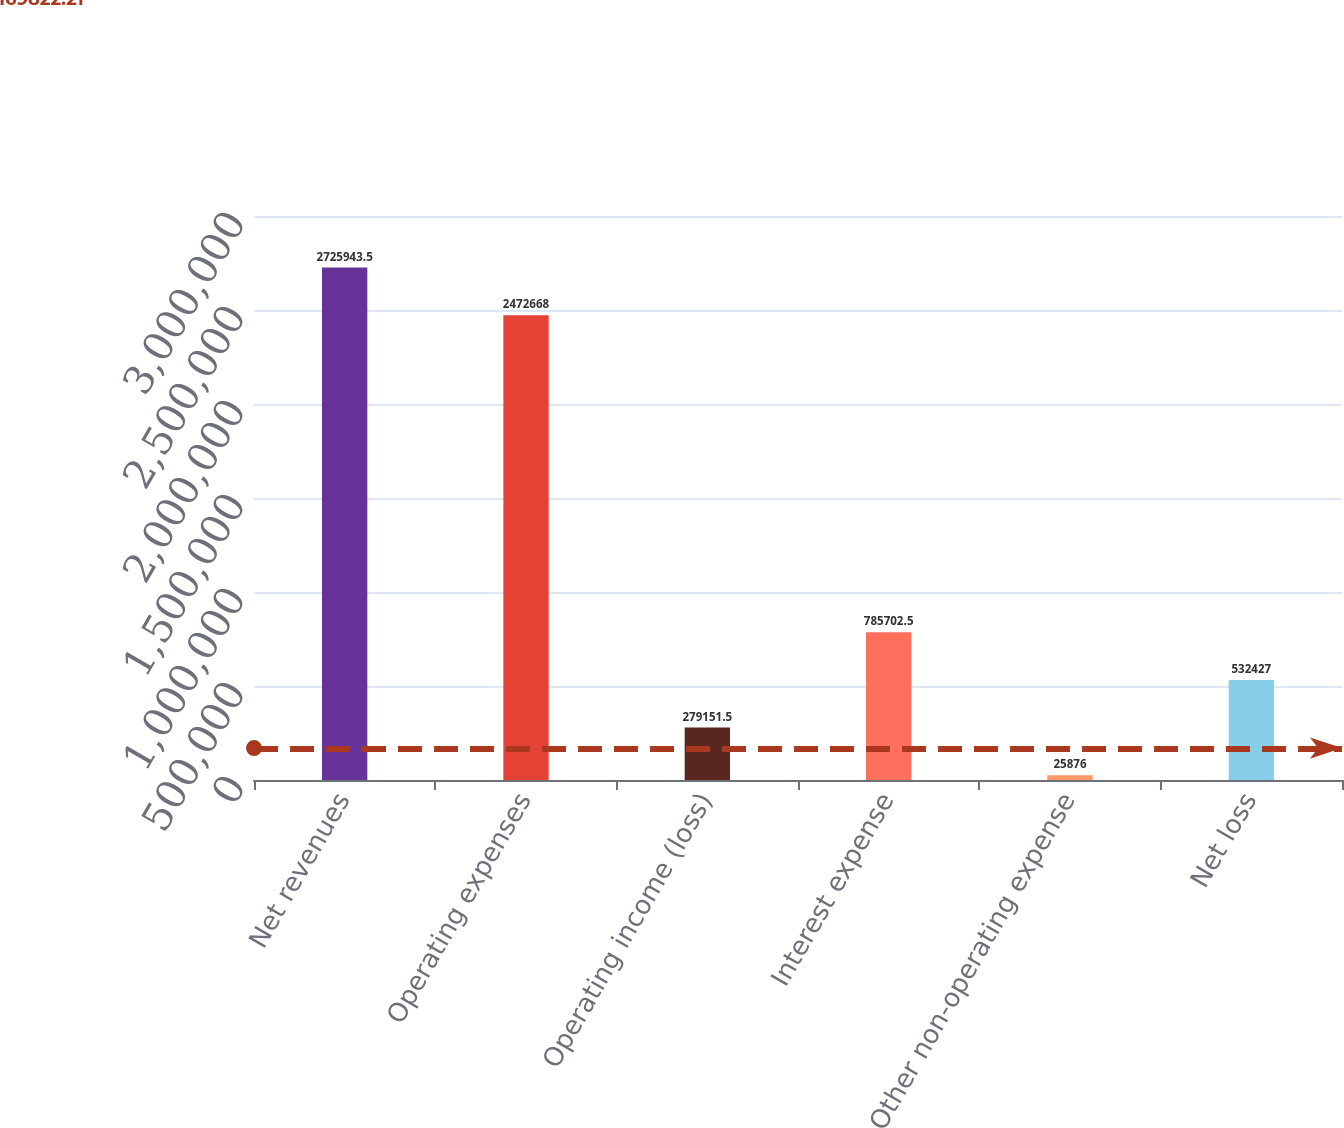Convert chart to OTSL. <chart><loc_0><loc_0><loc_500><loc_500><bar_chart><fcel>Net revenues<fcel>Operating expenses<fcel>Operating income (loss)<fcel>Interest expense<fcel>Other non-operating expense<fcel>Net loss<nl><fcel>2.72594e+06<fcel>2.47267e+06<fcel>279152<fcel>785702<fcel>25876<fcel>532427<nl></chart> 